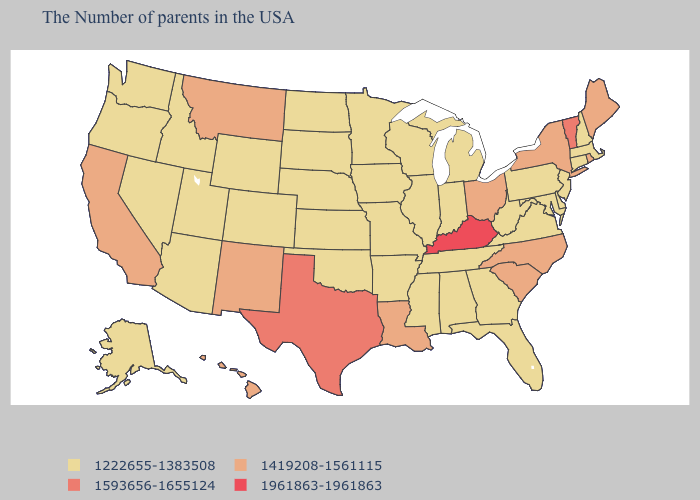What is the highest value in states that border Georgia?
Be succinct. 1419208-1561115. Does Montana have the highest value in the USA?
Give a very brief answer. No. What is the lowest value in the USA?
Quick response, please. 1222655-1383508. Does the map have missing data?
Give a very brief answer. No. What is the value of Alabama?
Be succinct. 1222655-1383508. Name the states that have a value in the range 1419208-1561115?
Give a very brief answer. Maine, Rhode Island, New York, North Carolina, South Carolina, Ohio, Louisiana, New Mexico, Montana, California, Hawaii. Does Colorado have a lower value than North Carolina?
Keep it brief. Yes. What is the value of Indiana?
Concise answer only. 1222655-1383508. What is the value of Arkansas?
Short answer required. 1222655-1383508. Does New Jersey have a lower value than South Carolina?
Answer briefly. Yes. Name the states that have a value in the range 1222655-1383508?
Give a very brief answer. Massachusetts, New Hampshire, Connecticut, New Jersey, Delaware, Maryland, Pennsylvania, Virginia, West Virginia, Florida, Georgia, Michigan, Indiana, Alabama, Tennessee, Wisconsin, Illinois, Mississippi, Missouri, Arkansas, Minnesota, Iowa, Kansas, Nebraska, Oklahoma, South Dakota, North Dakota, Wyoming, Colorado, Utah, Arizona, Idaho, Nevada, Washington, Oregon, Alaska. Which states have the highest value in the USA?
Keep it brief. Kentucky. Does the map have missing data?
Short answer required. No. Does the map have missing data?
Give a very brief answer. No. What is the highest value in the USA?
Keep it brief. 1961863-1961863. 